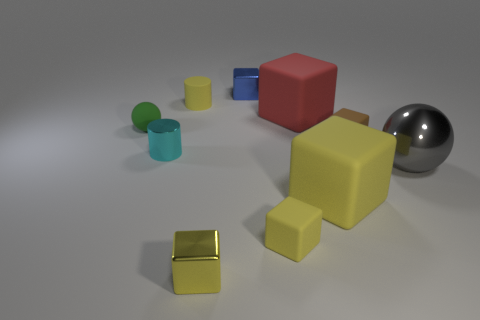How many tiny objects are either cyan shiny cylinders or blue cubes?
Offer a very short reply. 2. How many objects are either shiny blocks that are in front of the tiny brown thing or blue metallic objects?
Keep it short and to the point. 2. Is the color of the matte ball the same as the big shiny thing?
Your answer should be very brief. No. How many other things are there of the same shape as the blue metallic thing?
Your response must be concise. 5. What number of red things are either cylinders or shiny cubes?
Your answer should be compact. 0. What is the color of the cylinder that is the same material as the large red cube?
Make the answer very short. Yellow. Is the material of the big block behind the large gray ball the same as the thing that is on the left side of the small metal cylinder?
Ensure brevity in your answer.  Yes. There is a metal object that is the same color as the matte cylinder; what is its size?
Provide a succinct answer. Small. There is a large object behind the big metallic thing; what material is it?
Make the answer very short. Rubber. There is a small yellow object behind the tiny green sphere; is its shape the same as the large rubber object behind the big ball?
Keep it short and to the point. No. 